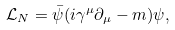<formula> <loc_0><loc_0><loc_500><loc_500>\mathcal { L } _ { N } = \bar { \psi } ( i { \gamma } ^ { \mu } { \partial } _ { \mu } - m ) { \psi } ,</formula> 